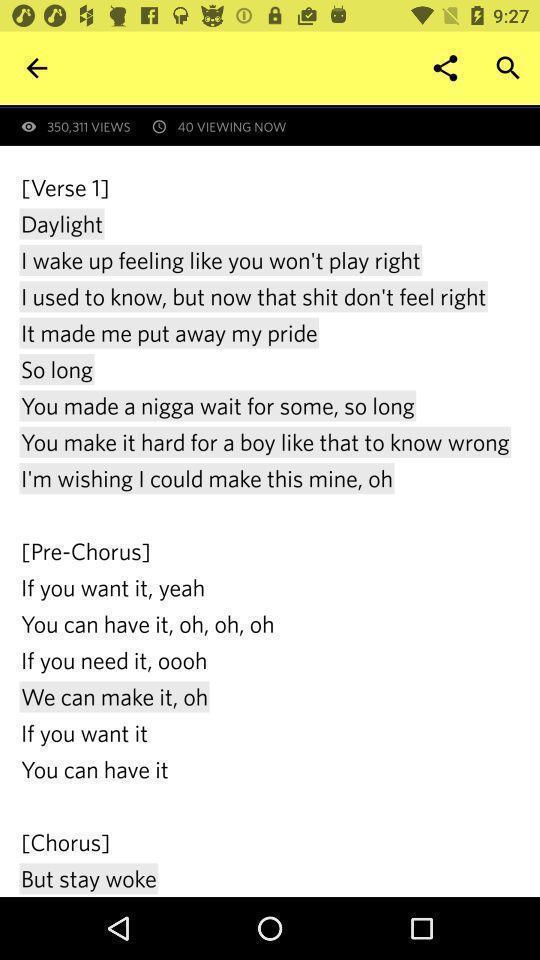What is the overall content of this screenshot? Page showing information about a poetry. 